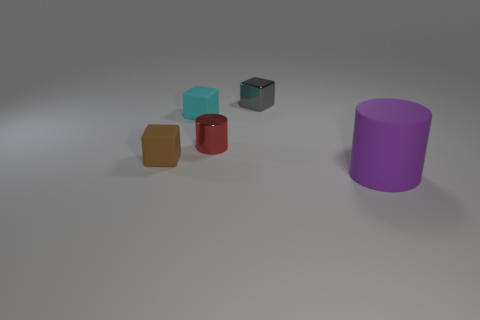Subtract all rubber cubes. How many cubes are left? 1 Subtract all red cylinders. How many cylinders are left? 1 Subtract all cubes. How many objects are left? 2 Subtract 2 cubes. How many cubes are left? 1 Subtract all cyan blocks. How many red cylinders are left? 1 Subtract all purple cubes. Subtract all yellow cylinders. How many cubes are left? 3 Subtract all red metallic cylinders. Subtract all brown rubber objects. How many objects are left? 3 Add 2 metal objects. How many metal objects are left? 4 Add 5 tiny rubber cubes. How many tiny rubber cubes exist? 7 Add 2 tiny metallic objects. How many objects exist? 7 